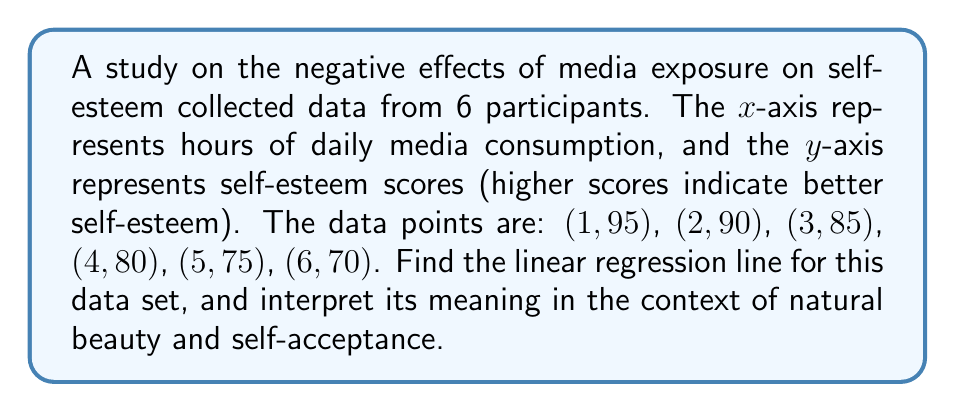Can you answer this question? To find the linear regression line, we'll use the formula $y = mx + b$, where $m$ is the slope and $b$ is the y-intercept.

Step 1: Calculate the means of x and y.
$\bar{x} = \frac{1+2+3+4+5+6}{6} = 3.5$
$\bar{y} = \frac{95+90+85+80+75+70}{6} = 82.5$

Step 2: Calculate the slope $m$ using the formula:
$m = \frac{\sum(x_i - \bar{x})(y_i - \bar{y})}{\sum(x_i - \bar{x})^2}$

$\sum(x_i - \bar{x})(y_i - \bar{y}) = (-2.5)(12.5) + (-1.5)(7.5) + (-0.5)(2.5) + (0.5)(-2.5) + (1.5)(-7.5) + (2.5)(-12.5) = -87.5$

$\sum(x_i - \bar{x})^2 = (-2.5)^2 + (-1.5)^2 + (-0.5)^2 + (0.5)^2 + (1.5)^2 + (2.5)^2 = 17.5$

$m = \frac{-87.5}{17.5} = -5$

Step 3: Calculate the y-intercept $b$ using the formula:
$b = \bar{y} - m\bar{x}$
$b = 82.5 - (-5)(3.5) = 100$

Therefore, the linear regression line is $y = -5x + 100$.

Interpretation: The negative slope (-5) indicates that for each additional hour of daily media consumption, self-esteem scores decrease by 5 points. This suggests that increased media exposure is associated with lower self-esteem, highlighting the importance of limiting media consumption and promoting natural beauty and self-acceptance.
Answer: $y = -5x + 100$ 